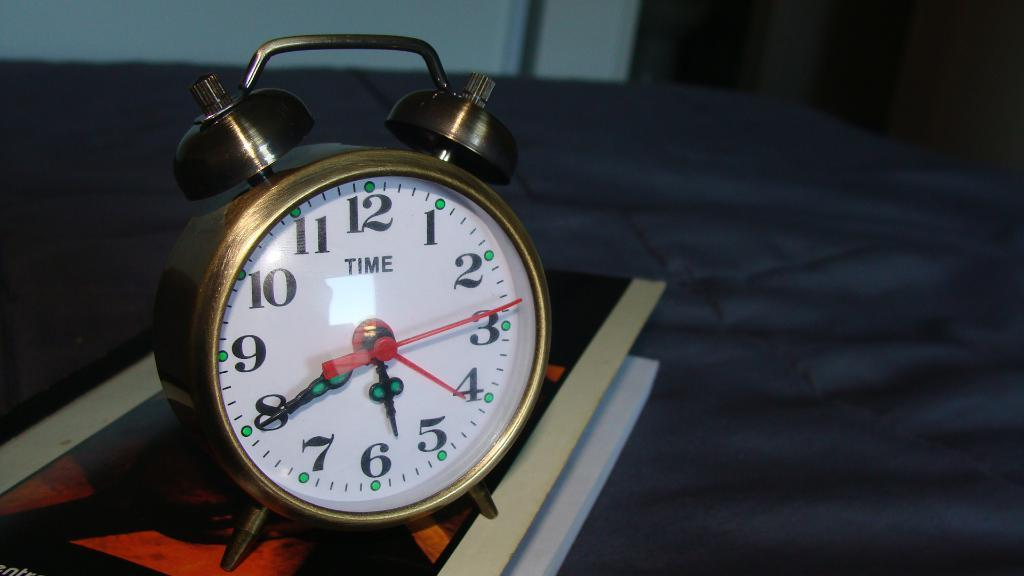Provide a one-sentence caption for the provided image. An old fashioned alarm clock displaying the time of 5:40. 